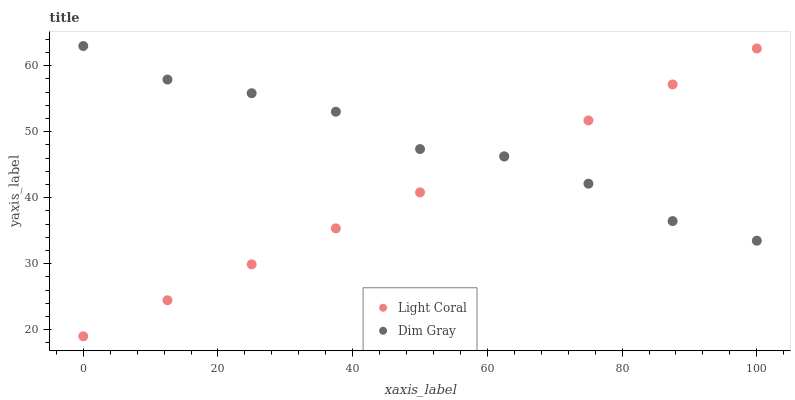Does Light Coral have the minimum area under the curve?
Answer yes or no. Yes. Does Dim Gray have the maximum area under the curve?
Answer yes or no. Yes. Does Dim Gray have the minimum area under the curve?
Answer yes or no. No. Is Light Coral the smoothest?
Answer yes or no. Yes. Is Dim Gray the roughest?
Answer yes or no. Yes. Is Dim Gray the smoothest?
Answer yes or no. No. Does Light Coral have the lowest value?
Answer yes or no. Yes. Does Dim Gray have the lowest value?
Answer yes or no. No. Does Dim Gray have the highest value?
Answer yes or no. Yes. Does Dim Gray intersect Light Coral?
Answer yes or no. Yes. Is Dim Gray less than Light Coral?
Answer yes or no. No. Is Dim Gray greater than Light Coral?
Answer yes or no. No. 